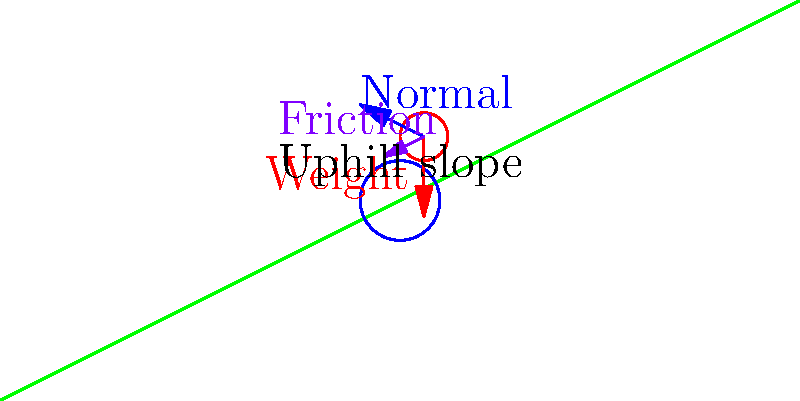A hiker is walking up a hill with a backpack. The backpack weighs 20 N. If the hill has an incline of 30°, what is the magnitude of the normal force acting on the backpack? To find the normal force acting on the backpack, we need to follow these steps:

1. Identify the forces acting on the backpack:
   - Weight (W): Always acts vertically downwards
   - Normal force (N): Perpendicular to the slope
   - Friction: Parallel to the slope (not needed for this calculation)

2. Resolve the weight vector into components parallel and perpendicular to the slope:
   - Weight perpendicular to slope: $W_{\perp} = W \cos \theta$
   - Weight parallel to slope: $W_{\parallel} = W \sin \theta$ (not needed for this calculation)

3. The normal force is equal in magnitude but opposite in direction to the weight component perpendicular to the slope:
   $N = W_{\perp} = W \cos \theta$

4. Given:
   - Weight of backpack (W) = 20 N
   - Angle of incline ($\theta$) = 30°

5. Calculate the normal force:
   $N = W \cos \theta$
   $N = 20 \cos 30°$
   $N = 20 \times \frac{\sqrt{3}}{2}$
   $N = 10\sqrt{3} \approx 17.32$ N

Therefore, the magnitude of the normal force acting on the backpack is $10\sqrt{3}$ N or approximately 17.32 N.
Answer: $10\sqrt{3}$ N 